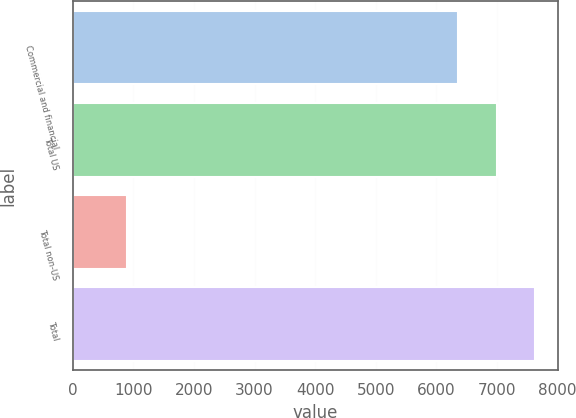Convert chart to OTSL. <chart><loc_0><loc_0><loc_500><loc_500><bar_chart><fcel>Commercial and financial<fcel>Total US<fcel>Total non-US<fcel>Total<nl><fcel>6357<fcel>6992.7<fcel>890<fcel>7628.4<nl></chart> 